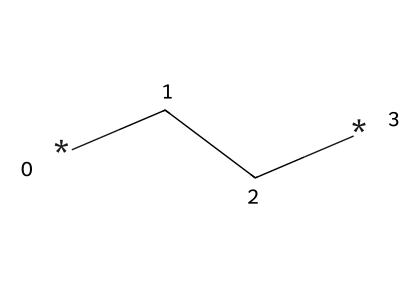What is the name of the chemical represented by this SMILES? The SMILES representation "CC" corresponds to a simple hydrocarbon with two carbon atoms, known as ethane.
Answer: ethane How many carbon atoms are present in this molecule? The SMILES "CC" indicates two atoms of carbon due to the two "C" characters.
Answer: 2 What is the type of bonds present in this molecule? The "CC" indicates a single bond between the two carbon atoms, as there are no multiple bonds indicated in the SMILES format.
Answer: single bond What is the degree of unsaturation in this molecule? The molecule has no double or triple bonds, and thus its degree of unsaturation is zero, indicating that it is a saturated hydrocarbon.
Answer: 0 How many hydrogen atoms are attached to this molecule? Each carbon in a saturated hydrocarbon like ethane can bond with up to four hydrogen atoms. With two carbons, the total number of hydrogen atoms is calculated as (2 * 2) + 2 = 6.
Answer: 6 Why is polyethylene used in insulation for electronic cables? The simple structure of polyethylene, being a polymer made from ethylene, provides excellent electrical insulation properties due to its high resistance to electrical current.
Answer: high resistance What type of hydrocarbon is represented by the structure? Since the structure "CC" indicates a fully saturated hydrocarbon with single bonds and no rings or functional groups, it is classified as an alkane.
Answer: alkane 